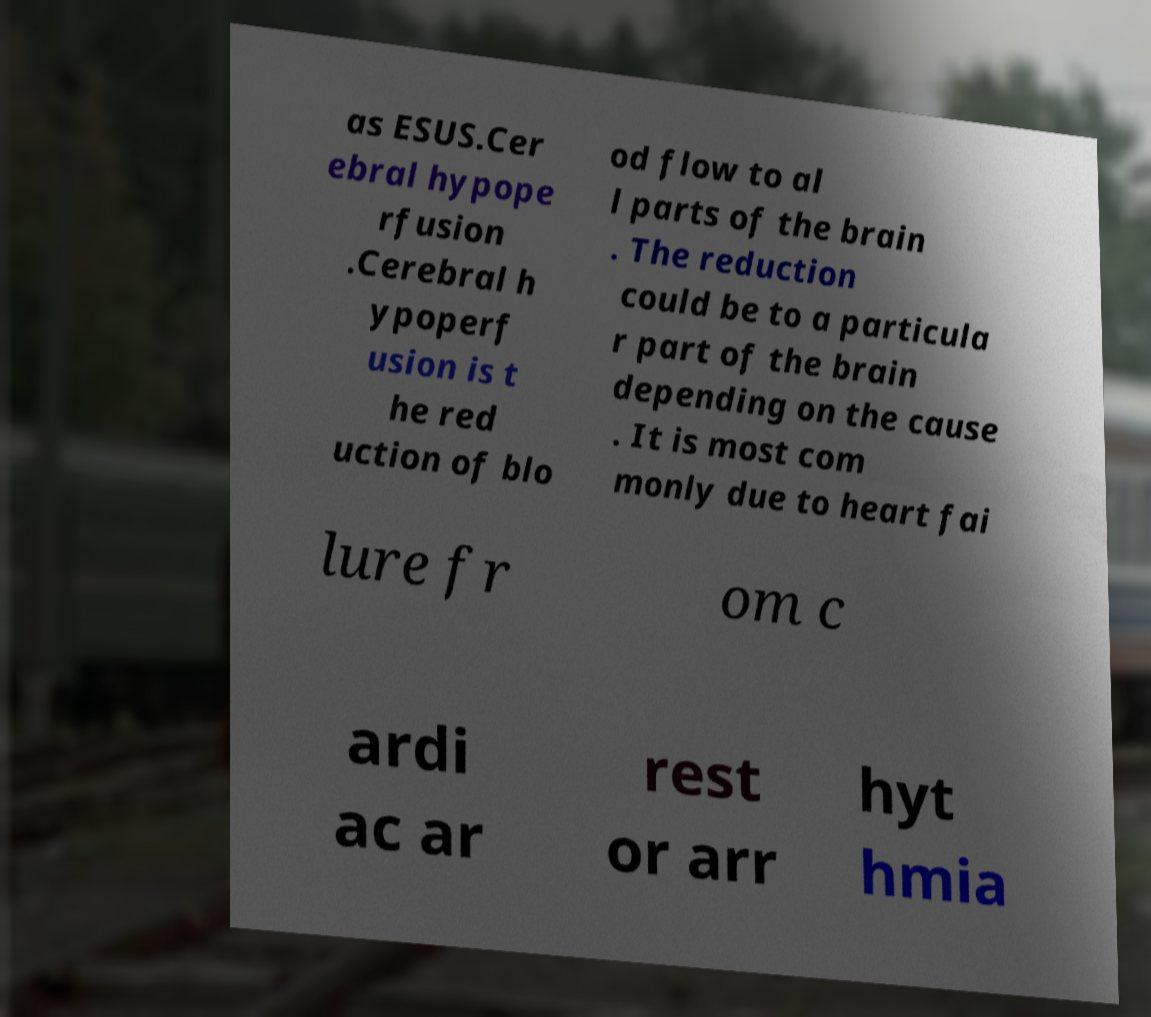What messages or text are displayed in this image? I need them in a readable, typed format. as ESUS.Cer ebral hypope rfusion .Cerebral h ypoperf usion is t he red uction of blo od flow to al l parts of the brain . The reduction could be to a particula r part of the brain depending on the cause . It is most com monly due to heart fai lure fr om c ardi ac ar rest or arr hyt hmia 